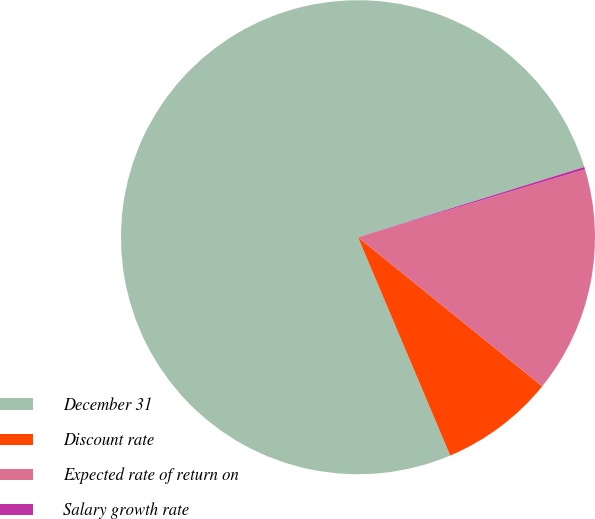Convert chart. <chart><loc_0><loc_0><loc_500><loc_500><pie_chart><fcel>December 31<fcel>Discount rate<fcel>Expected rate of return on<fcel>Salary growth rate<nl><fcel>76.57%<fcel>7.81%<fcel>15.45%<fcel>0.17%<nl></chart> 